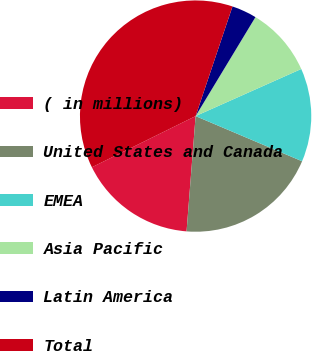Convert chart. <chart><loc_0><loc_0><loc_500><loc_500><pie_chart><fcel>( in millions)<fcel>United States and Canada<fcel>EMEA<fcel>Asia Pacific<fcel>Latin America<fcel>Total<nl><fcel>16.46%<fcel>19.86%<fcel>13.06%<fcel>9.67%<fcel>3.49%<fcel>37.46%<nl></chart> 